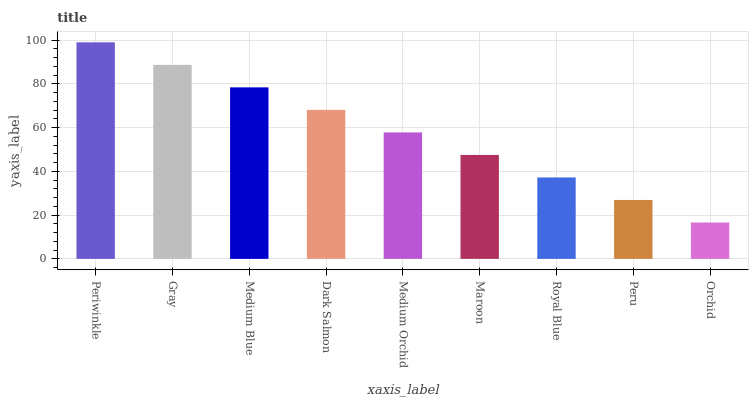Is Orchid the minimum?
Answer yes or no. Yes. Is Periwinkle the maximum?
Answer yes or no. Yes. Is Gray the minimum?
Answer yes or no. No. Is Gray the maximum?
Answer yes or no. No. Is Periwinkle greater than Gray?
Answer yes or no. Yes. Is Gray less than Periwinkle?
Answer yes or no. Yes. Is Gray greater than Periwinkle?
Answer yes or no. No. Is Periwinkle less than Gray?
Answer yes or no. No. Is Medium Orchid the high median?
Answer yes or no. Yes. Is Medium Orchid the low median?
Answer yes or no. Yes. Is Peru the high median?
Answer yes or no. No. Is Gray the low median?
Answer yes or no. No. 